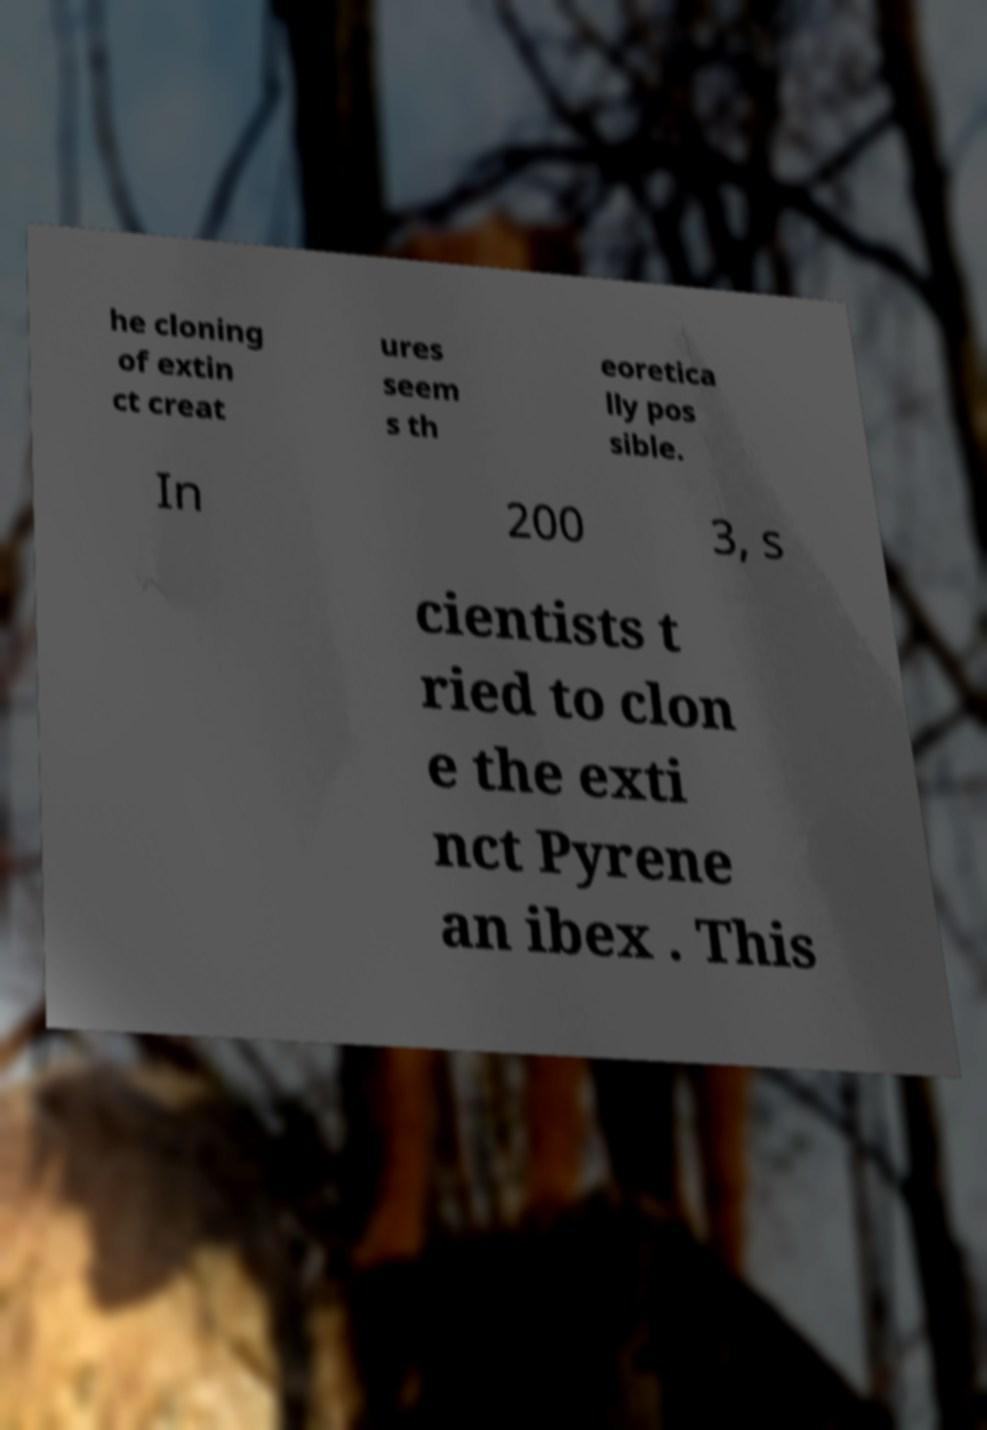Can you read and provide the text displayed in the image?This photo seems to have some interesting text. Can you extract and type it out for me? he cloning of extin ct creat ures seem s th eoretica lly pos sible. In 200 3, s cientists t ried to clon e the exti nct Pyrene an ibex . This 